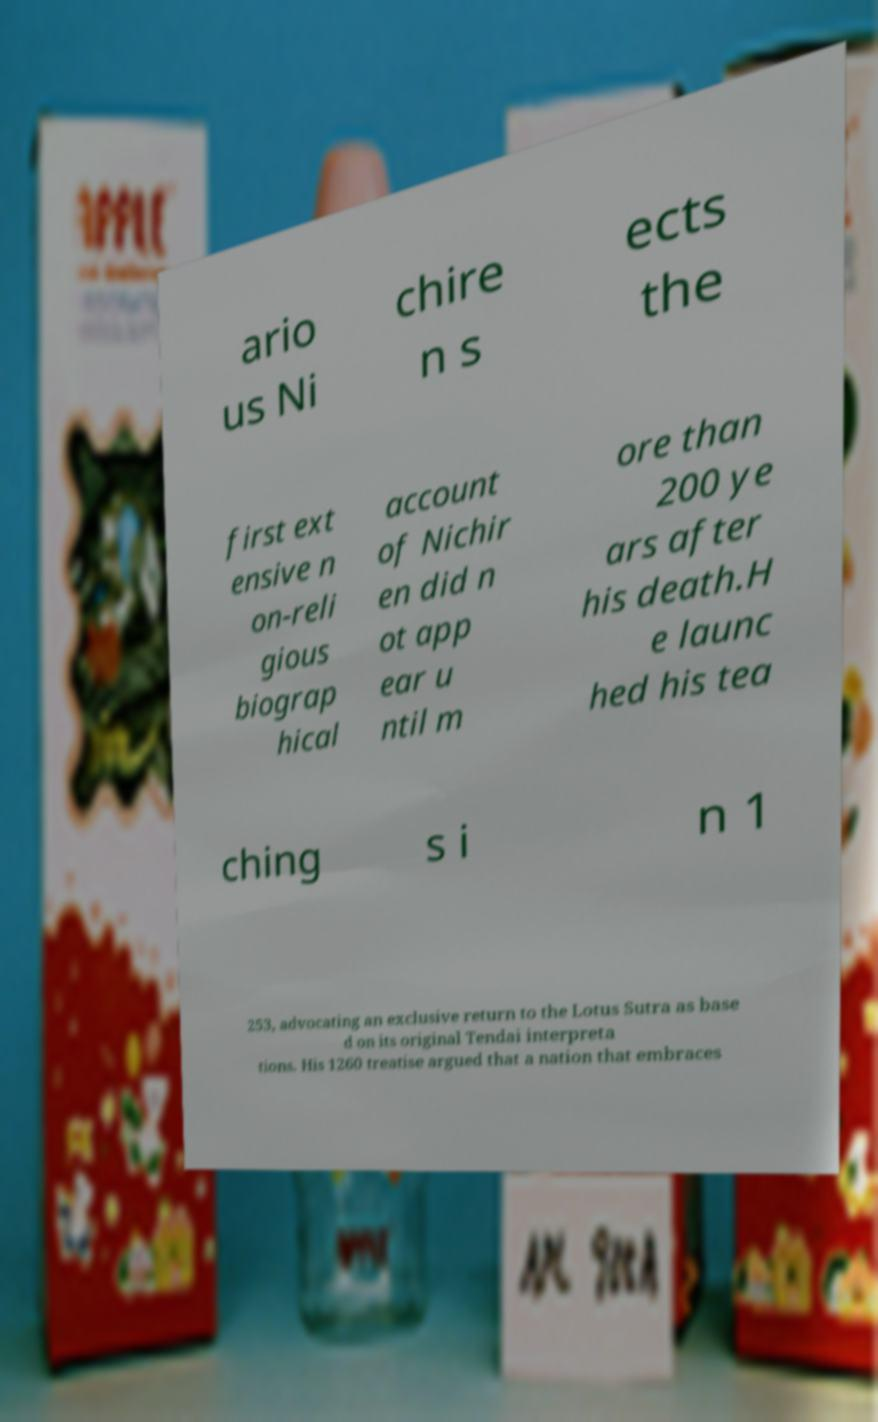Please read and relay the text visible in this image. What does it say? ario us Ni chire n s ects the first ext ensive n on-reli gious biograp hical account of Nichir en did n ot app ear u ntil m ore than 200 ye ars after his death.H e launc hed his tea ching s i n 1 253, advocating an exclusive return to the Lotus Sutra as base d on its original Tendai interpreta tions. His 1260 treatise argued that a nation that embraces 